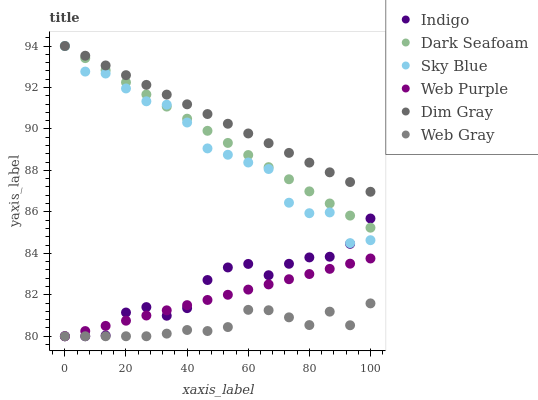Does Web Gray have the minimum area under the curve?
Answer yes or no. Yes. Does Dim Gray have the maximum area under the curve?
Answer yes or no. Yes. Does Indigo have the minimum area under the curve?
Answer yes or no. No. Does Indigo have the maximum area under the curve?
Answer yes or no. No. Is Dim Gray the smoothest?
Answer yes or no. Yes. Is Sky Blue the roughest?
Answer yes or no. Yes. Is Indigo the smoothest?
Answer yes or no. No. Is Indigo the roughest?
Answer yes or no. No. Does Web Gray have the lowest value?
Answer yes or no. Yes. Does Dark Seafoam have the lowest value?
Answer yes or no. No. Does Sky Blue have the highest value?
Answer yes or no. Yes. Does Indigo have the highest value?
Answer yes or no. No. Is Web Gray less than Sky Blue?
Answer yes or no. Yes. Is Dim Gray greater than Indigo?
Answer yes or no. Yes. Does Indigo intersect Web Gray?
Answer yes or no. Yes. Is Indigo less than Web Gray?
Answer yes or no. No. Is Indigo greater than Web Gray?
Answer yes or no. No. Does Web Gray intersect Sky Blue?
Answer yes or no. No. 